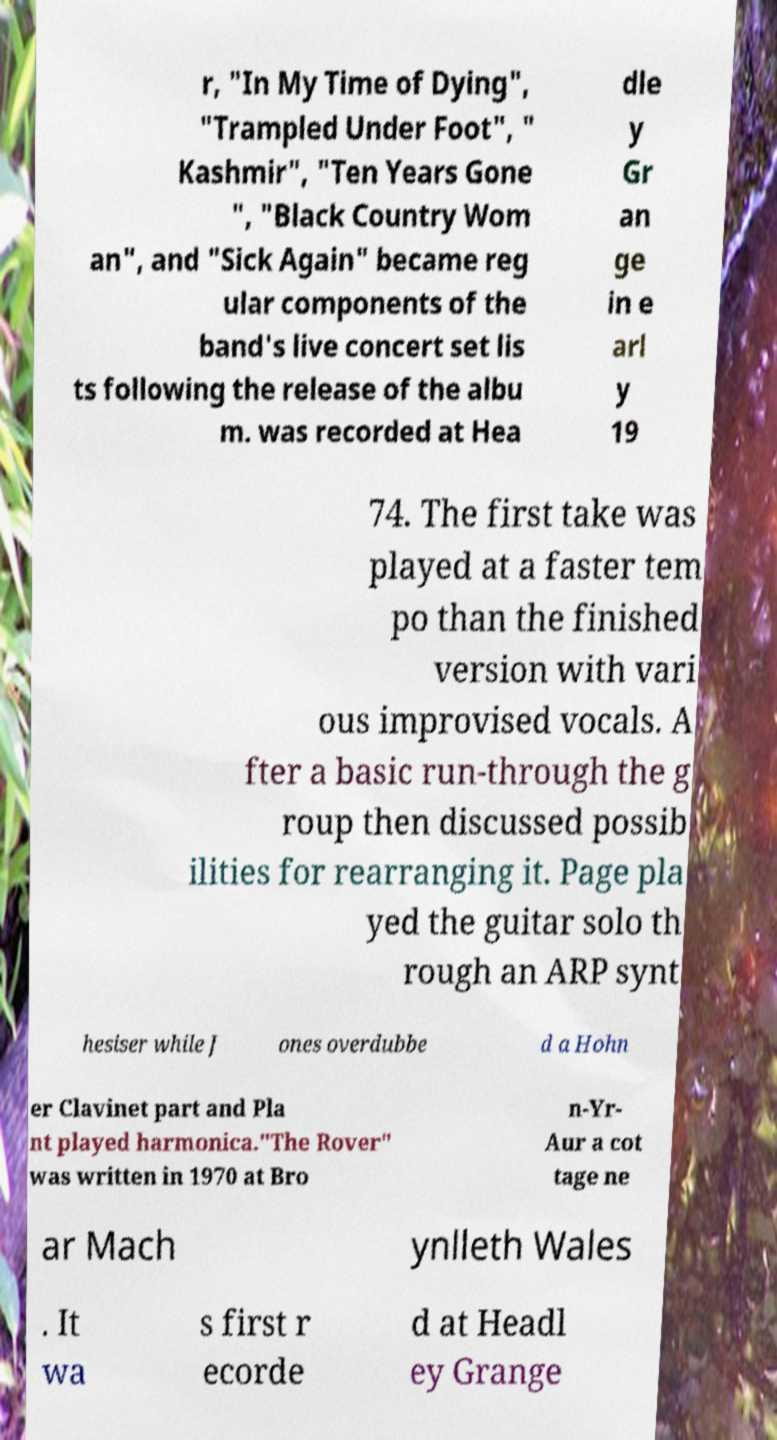Please read and relay the text visible in this image. What does it say? r, "In My Time of Dying", "Trampled Under Foot", " Kashmir", "Ten Years Gone ", "Black Country Wom an", and "Sick Again" became reg ular components of the band's live concert set lis ts following the release of the albu m. was recorded at Hea dle y Gr an ge in e arl y 19 74. The first take was played at a faster tem po than the finished version with vari ous improvised vocals. A fter a basic run-through the g roup then discussed possib ilities for rearranging it. Page pla yed the guitar solo th rough an ARP synt hesiser while J ones overdubbe d a Hohn er Clavinet part and Pla nt played harmonica."The Rover" was written in 1970 at Bro n-Yr- Aur a cot tage ne ar Mach ynlleth Wales . It wa s first r ecorde d at Headl ey Grange 